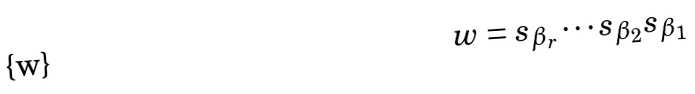Convert formula to latex. <formula><loc_0><loc_0><loc_500><loc_500>w = s _ { \beta _ { r } } \cdots s _ { \beta _ { 2 } } s _ { \beta _ { 1 } }</formula> 